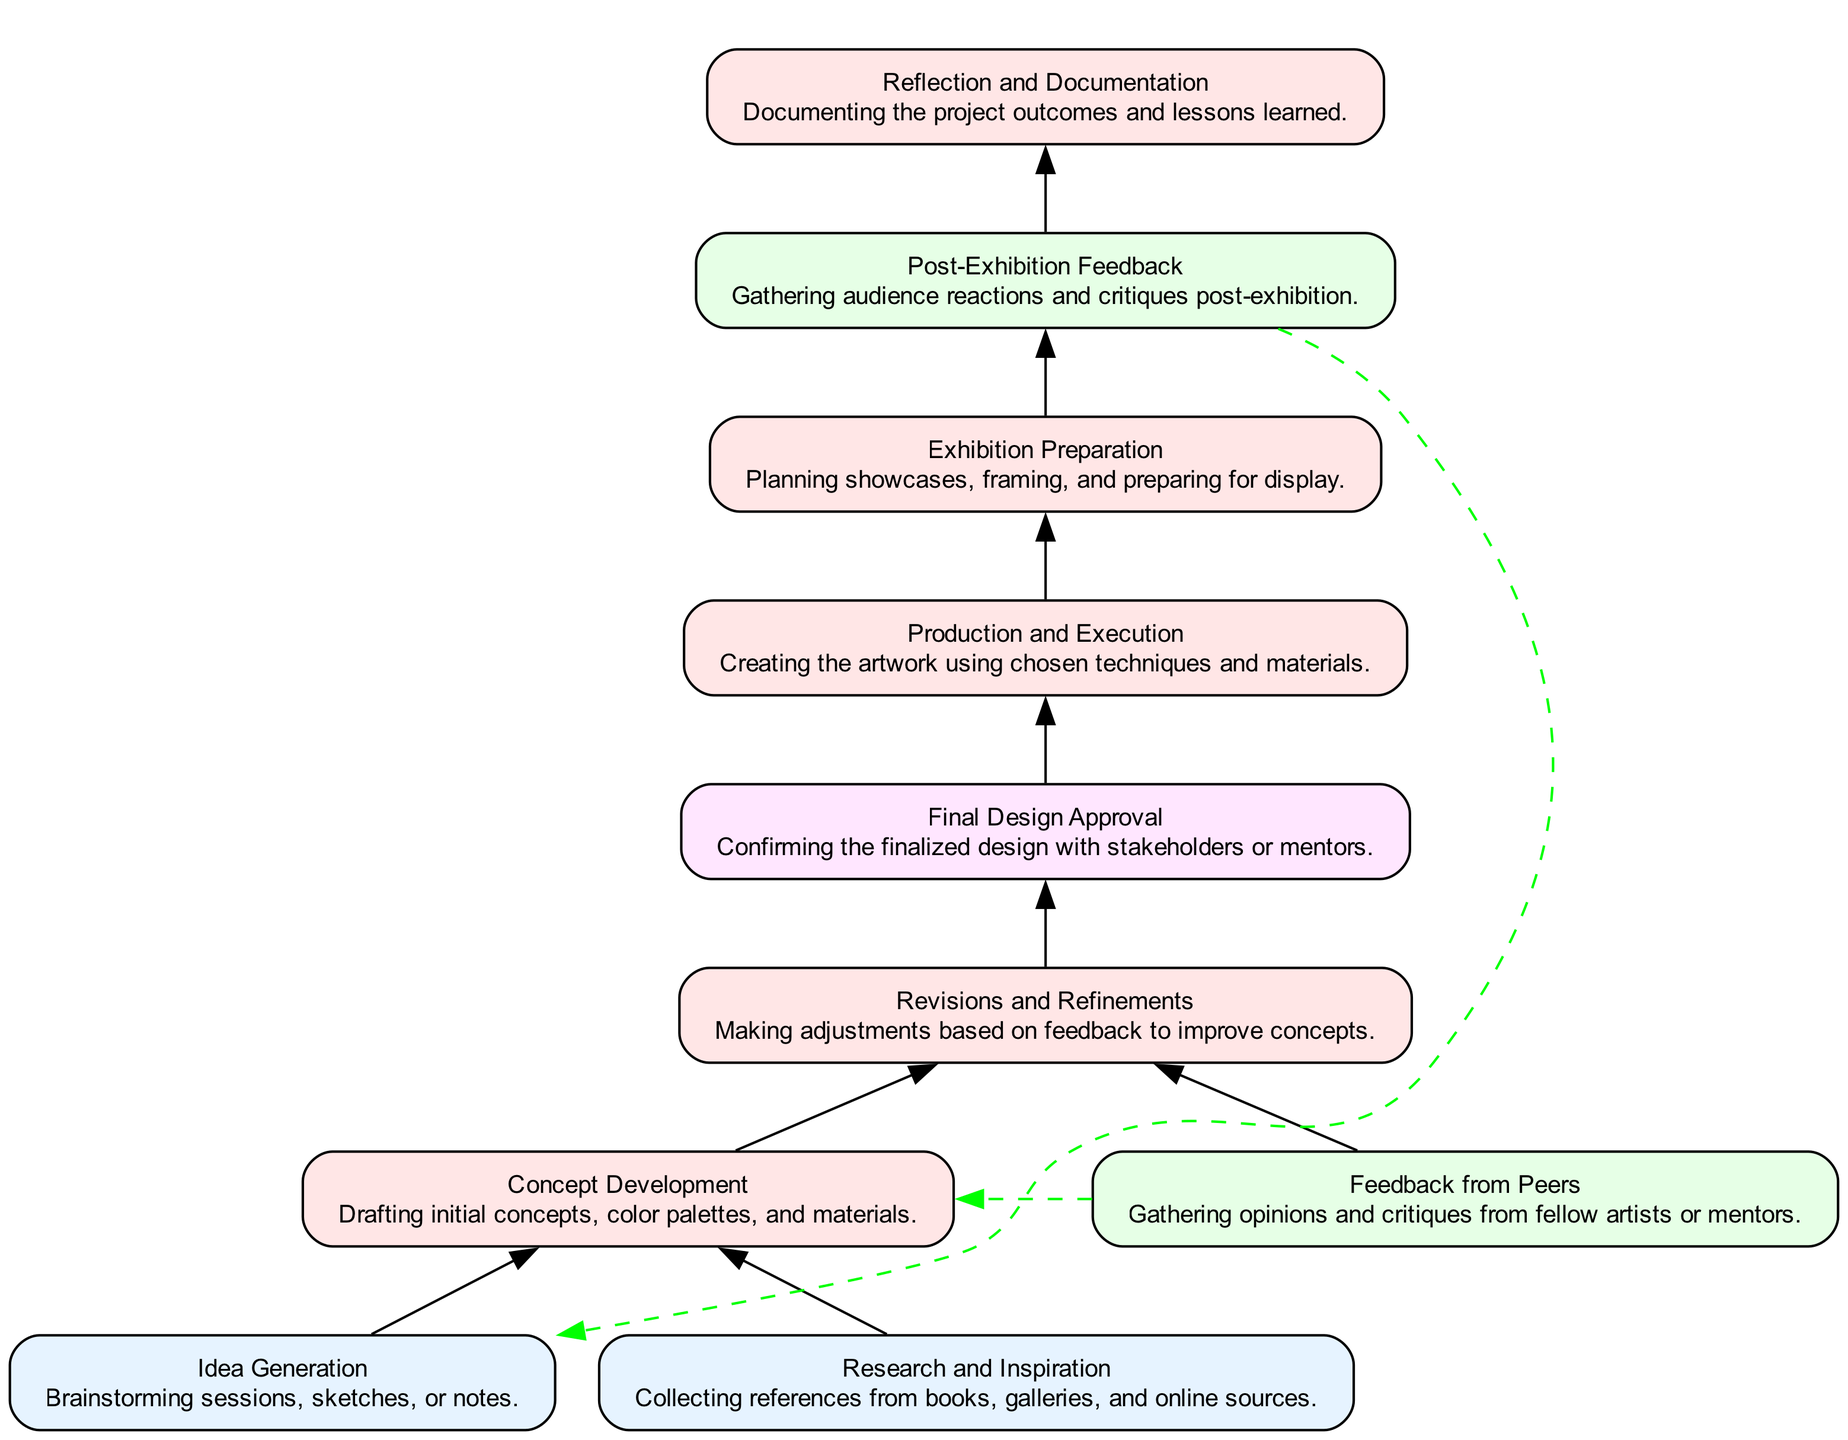What are the first two elements in the workflow? The first two elements as per the flowchart are 'Idea Generation' and 'Research and Inspiration'. These are the starting points before moving to 'Concept Development'.
Answer: Idea Generation, Research and Inspiration How many feedback loops are present in the diagram? The diagram illustrates two feedback loops: one from 'Feedback from Peers' to 'Concept Development', and another from 'Post-Exhibition Feedback' to 'Idea Generation'.
Answer: 2 What is the final step in the art project workflow? The last process in the workflow is 'Reflection and Documentation', which follows 'Post-Exhibition Feedback'. This step focuses on documenting outcomes and lessons from the project.
Answer: Reflection and Documentation Which node connects to both 'Revisions and Refinements' and 'Final Design Approval'? The connecting node is 'Concept Development', which routes directly to both subsequent processes, indicating that revisions occur before the final design can be approved.
Answer: Concept Development What type of process is 'Exhibition Preparation'? 'Exhibition Preparation' is classified as a 'Process'. This is evident from its description and the diagram indicates it represents an action in the workflow.
Answer: Process What is the main purpose of 'Post-Exhibition Feedback'? The primary purpose of 'Post-Exhibition Feedback' is to gather audience reactions and critiques after the artwork is displayed, providing insights for the artist.
Answer: Gathering audience reactions What links lead back to 'Idea Generation' in the feedback loop? The feedback loop from 'Post-Exhibition Feedback' leads back to 'Idea Generation'. This indicates that feedback received influences future idea generation for new projects.
Answer: Post-Exhibition Feedback How many nodes are described as 'Process'? There are four nodes that are categorized as 'Process': 'Concept Development', 'Revisions and Refinements', 'Production and Execution', and 'Exhibition Preparation'.
Answer: 4 What is required for moving from 'Revisions and Refinements' to 'Final Design Approval'? The transition from 'Revisions and Refinements' to 'Final Design Approval' requires the completion of conceptual adjustments, indicating acceptance of revisions before final approval.
Answer: Completion of revisions 